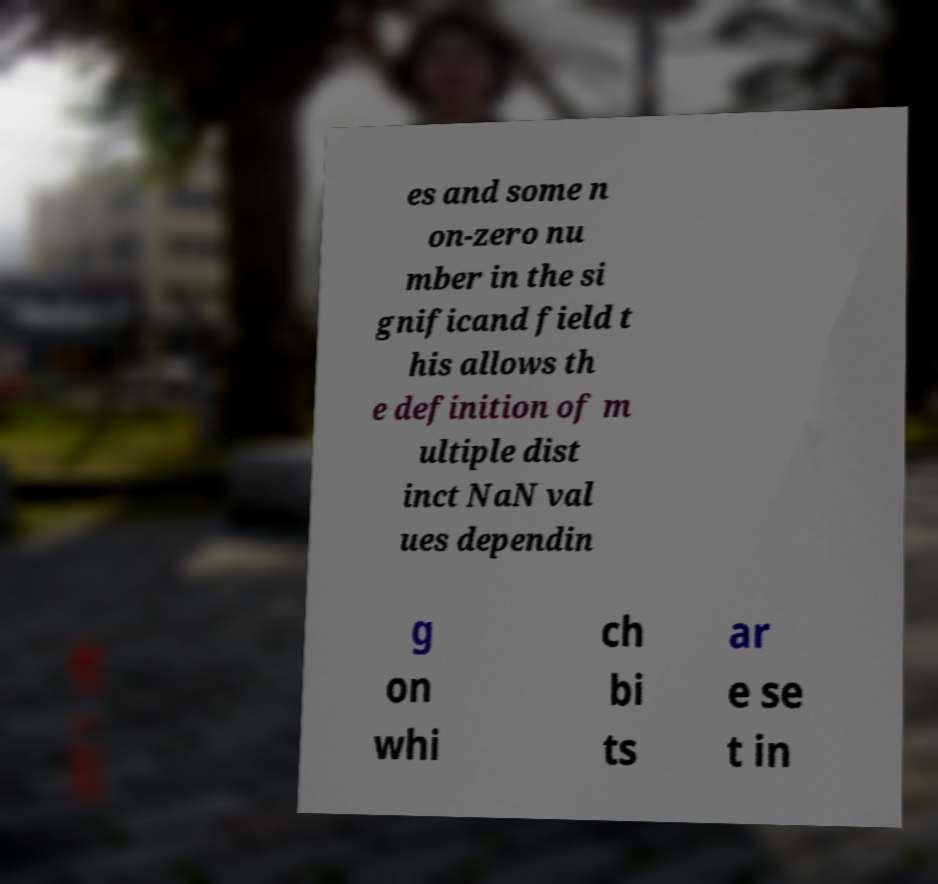Can you read and provide the text displayed in the image?This photo seems to have some interesting text. Can you extract and type it out for me? es and some n on-zero nu mber in the si gnificand field t his allows th e definition of m ultiple dist inct NaN val ues dependin g on whi ch bi ts ar e se t in 